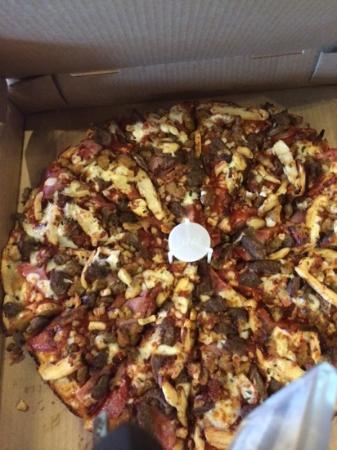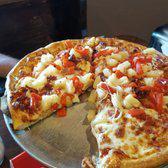The first image is the image on the left, the second image is the image on the right. Evaluate the accuracy of this statement regarding the images: "No pizza is missing a slice, but the pizza on the left has one slice out of alignment with the rest and is on a silver tray.". Is it true? Answer yes or no. No. The first image is the image on the left, the second image is the image on the right. Analyze the images presented: Is the assertion "There are at least 8 slices of a pizza sitting on top of a silver circle plate." valid? Answer yes or no. No. 